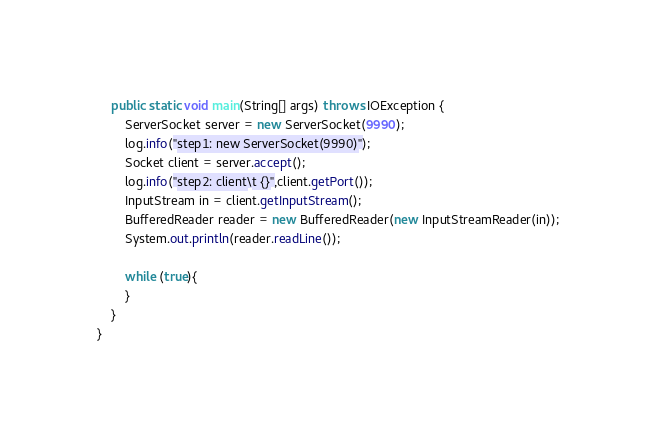<code> <loc_0><loc_0><loc_500><loc_500><_Java_>
    public static void main(String[] args) throws IOException {
        ServerSocket server = new ServerSocket(9990);
        log.info("step1: new ServerSocket(9990)");
        Socket client = server.accept();
        log.info("step2: client\t {}",client.getPort());
        InputStream in = client.getInputStream();
        BufferedReader reader = new BufferedReader(new InputStreamReader(in));
        System.out.println(reader.readLine());

        while (true){
        }
    }
}
</code> 